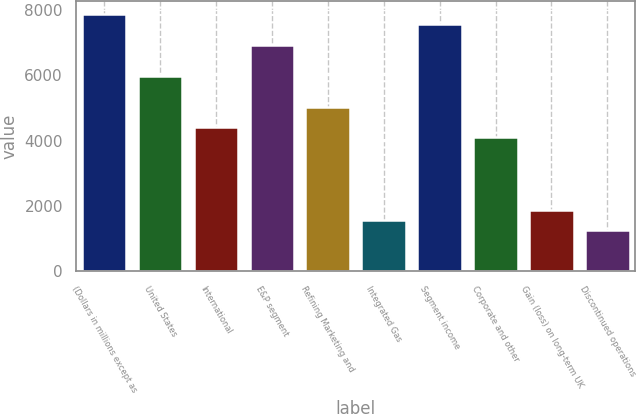Convert chart. <chart><loc_0><loc_0><loc_500><loc_500><bar_chart><fcel>(Dollars in millions except as<fcel>United States<fcel>International<fcel>E&P segment<fcel>Refining Marketing and<fcel>Integrated Gas<fcel>Segment income<fcel>Corporate and other<fcel>Gain (loss) on long-term UK<fcel>Discontinued operations<nl><fcel>7879.87<fcel>5988.73<fcel>4412.78<fcel>6934.3<fcel>5043.16<fcel>1576.07<fcel>7564.68<fcel>4097.59<fcel>1891.26<fcel>1260.88<nl></chart> 